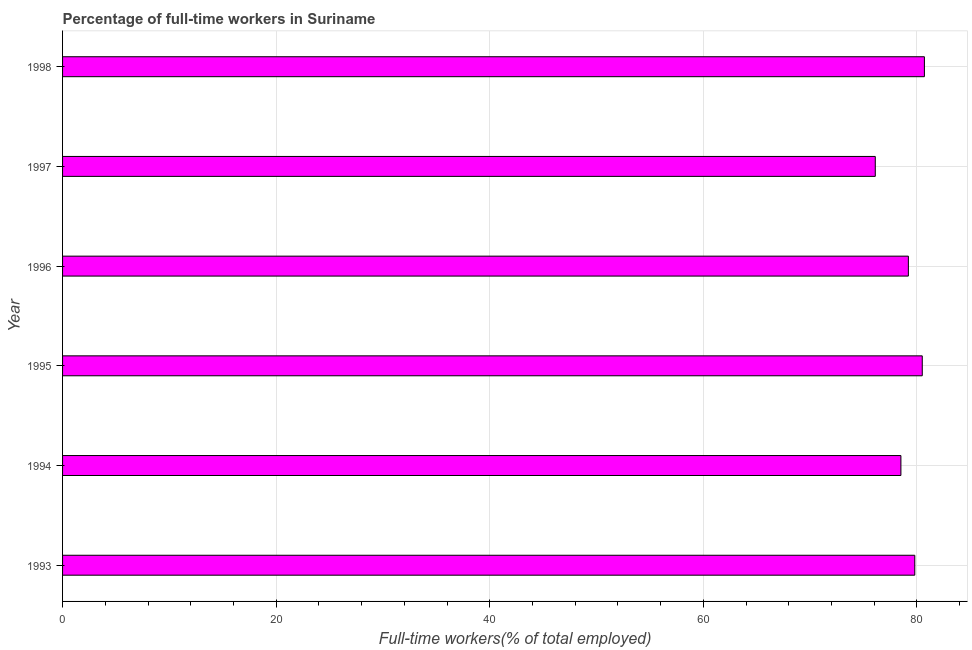Does the graph contain grids?
Give a very brief answer. Yes. What is the title of the graph?
Provide a succinct answer. Percentage of full-time workers in Suriname. What is the label or title of the X-axis?
Offer a very short reply. Full-time workers(% of total employed). What is the percentage of full-time workers in 1996?
Ensure brevity in your answer.  79.2. Across all years, what is the maximum percentage of full-time workers?
Provide a succinct answer. 80.7. Across all years, what is the minimum percentage of full-time workers?
Your answer should be compact. 76.1. In which year was the percentage of full-time workers maximum?
Offer a very short reply. 1998. In which year was the percentage of full-time workers minimum?
Your answer should be compact. 1997. What is the sum of the percentage of full-time workers?
Keep it short and to the point. 474.8. What is the difference between the percentage of full-time workers in 1995 and 1998?
Your answer should be compact. -0.2. What is the average percentage of full-time workers per year?
Your answer should be very brief. 79.13. What is the median percentage of full-time workers?
Give a very brief answer. 79.5. Is the difference between the percentage of full-time workers in 1995 and 1997 greater than the difference between any two years?
Give a very brief answer. No. Is the sum of the percentage of full-time workers in 1995 and 1997 greater than the maximum percentage of full-time workers across all years?
Make the answer very short. Yes. What is the difference between the highest and the lowest percentage of full-time workers?
Give a very brief answer. 4.6. In how many years, is the percentage of full-time workers greater than the average percentage of full-time workers taken over all years?
Ensure brevity in your answer.  4. How many bars are there?
Give a very brief answer. 6. Are the values on the major ticks of X-axis written in scientific E-notation?
Make the answer very short. No. What is the Full-time workers(% of total employed) in 1993?
Your response must be concise. 79.8. What is the Full-time workers(% of total employed) of 1994?
Keep it short and to the point. 78.5. What is the Full-time workers(% of total employed) in 1995?
Make the answer very short. 80.5. What is the Full-time workers(% of total employed) in 1996?
Ensure brevity in your answer.  79.2. What is the Full-time workers(% of total employed) in 1997?
Offer a terse response. 76.1. What is the Full-time workers(% of total employed) in 1998?
Make the answer very short. 80.7. What is the difference between the Full-time workers(% of total employed) in 1993 and 1994?
Your answer should be compact. 1.3. What is the difference between the Full-time workers(% of total employed) in 1993 and 1995?
Ensure brevity in your answer.  -0.7. What is the difference between the Full-time workers(% of total employed) in 1993 and 1996?
Your answer should be compact. 0.6. What is the difference between the Full-time workers(% of total employed) in 1993 and 1997?
Provide a short and direct response. 3.7. What is the difference between the Full-time workers(% of total employed) in 1993 and 1998?
Make the answer very short. -0.9. What is the difference between the Full-time workers(% of total employed) in 1994 and 1998?
Your response must be concise. -2.2. What is the difference between the Full-time workers(% of total employed) in 1995 and 1998?
Provide a succinct answer. -0.2. What is the difference between the Full-time workers(% of total employed) in 1996 and 1998?
Make the answer very short. -1.5. What is the ratio of the Full-time workers(% of total employed) in 1993 to that in 1994?
Keep it short and to the point. 1.02. What is the ratio of the Full-time workers(% of total employed) in 1993 to that in 1995?
Give a very brief answer. 0.99. What is the ratio of the Full-time workers(% of total employed) in 1993 to that in 1996?
Your answer should be compact. 1.01. What is the ratio of the Full-time workers(% of total employed) in 1993 to that in 1997?
Keep it short and to the point. 1.05. What is the ratio of the Full-time workers(% of total employed) in 1994 to that in 1995?
Offer a very short reply. 0.97. What is the ratio of the Full-time workers(% of total employed) in 1994 to that in 1996?
Your response must be concise. 0.99. What is the ratio of the Full-time workers(% of total employed) in 1994 to that in 1997?
Offer a terse response. 1.03. What is the ratio of the Full-time workers(% of total employed) in 1994 to that in 1998?
Make the answer very short. 0.97. What is the ratio of the Full-time workers(% of total employed) in 1995 to that in 1996?
Provide a succinct answer. 1.02. What is the ratio of the Full-time workers(% of total employed) in 1995 to that in 1997?
Make the answer very short. 1.06. What is the ratio of the Full-time workers(% of total employed) in 1995 to that in 1998?
Your response must be concise. 1. What is the ratio of the Full-time workers(% of total employed) in 1996 to that in 1997?
Provide a succinct answer. 1.04. What is the ratio of the Full-time workers(% of total employed) in 1996 to that in 1998?
Provide a succinct answer. 0.98. What is the ratio of the Full-time workers(% of total employed) in 1997 to that in 1998?
Give a very brief answer. 0.94. 